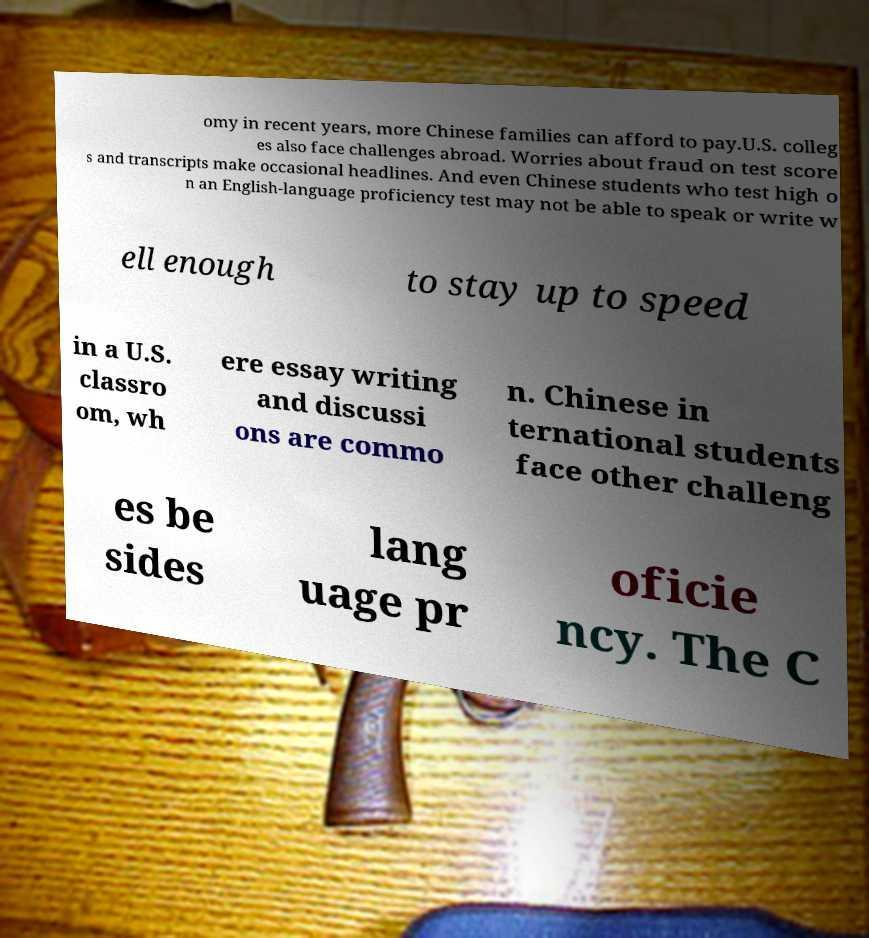Could you assist in decoding the text presented in this image and type it out clearly? omy in recent years, more Chinese families can afford to pay.U.S. colleg es also face challenges abroad. Worries about fraud on test score s and transcripts make occasional headlines. And even Chinese students who test high o n an English-language proficiency test may not be able to speak or write w ell enough to stay up to speed in a U.S. classro om, wh ere essay writing and discussi ons are commo n. Chinese in ternational students face other challeng es be sides lang uage pr oficie ncy. The C 